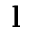<formula> <loc_0><loc_0><loc_500><loc_500>l</formula> 